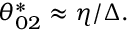<formula> <loc_0><loc_0><loc_500><loc_500>\theta _ { 0 2 } ^ { * } \approx \eta / \Delta .</formula> 